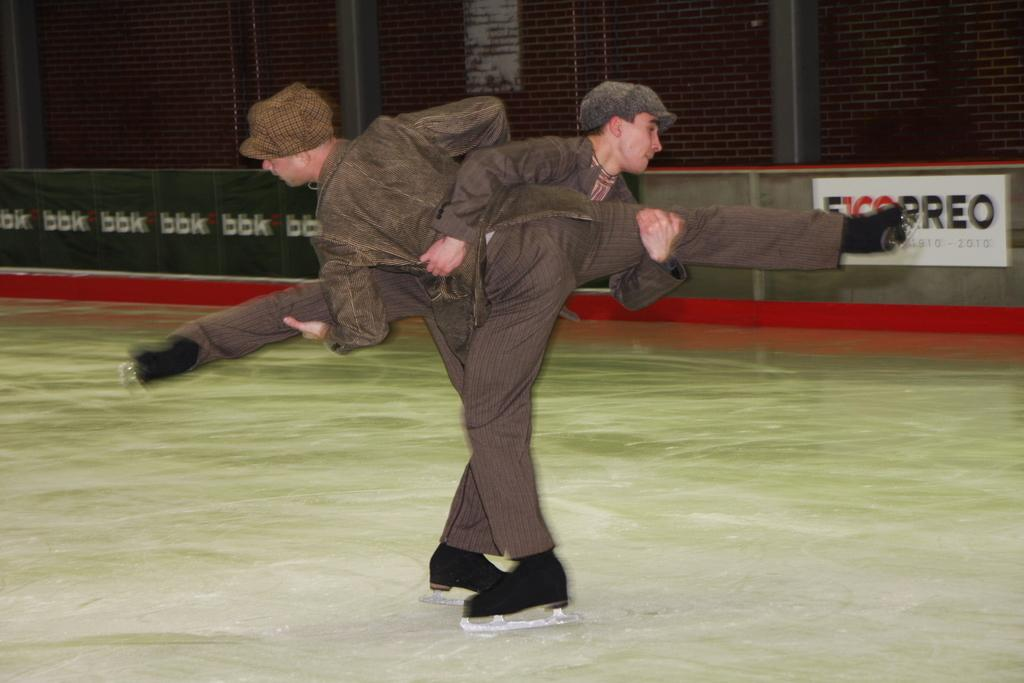How many people are in the image? There are two people in the image. What are the two people doing in the image? The two people are holding each other and skating on the ice. What can be seen in the background of the image? There is a board and a wall in the background of the image. What type of protest is happening in the image? There is no protest present in the image; it features two people skating on the ice. Can you tell me the relationship between the two people in the image? The provided facts do not specify the relationship between the two people in the image. 